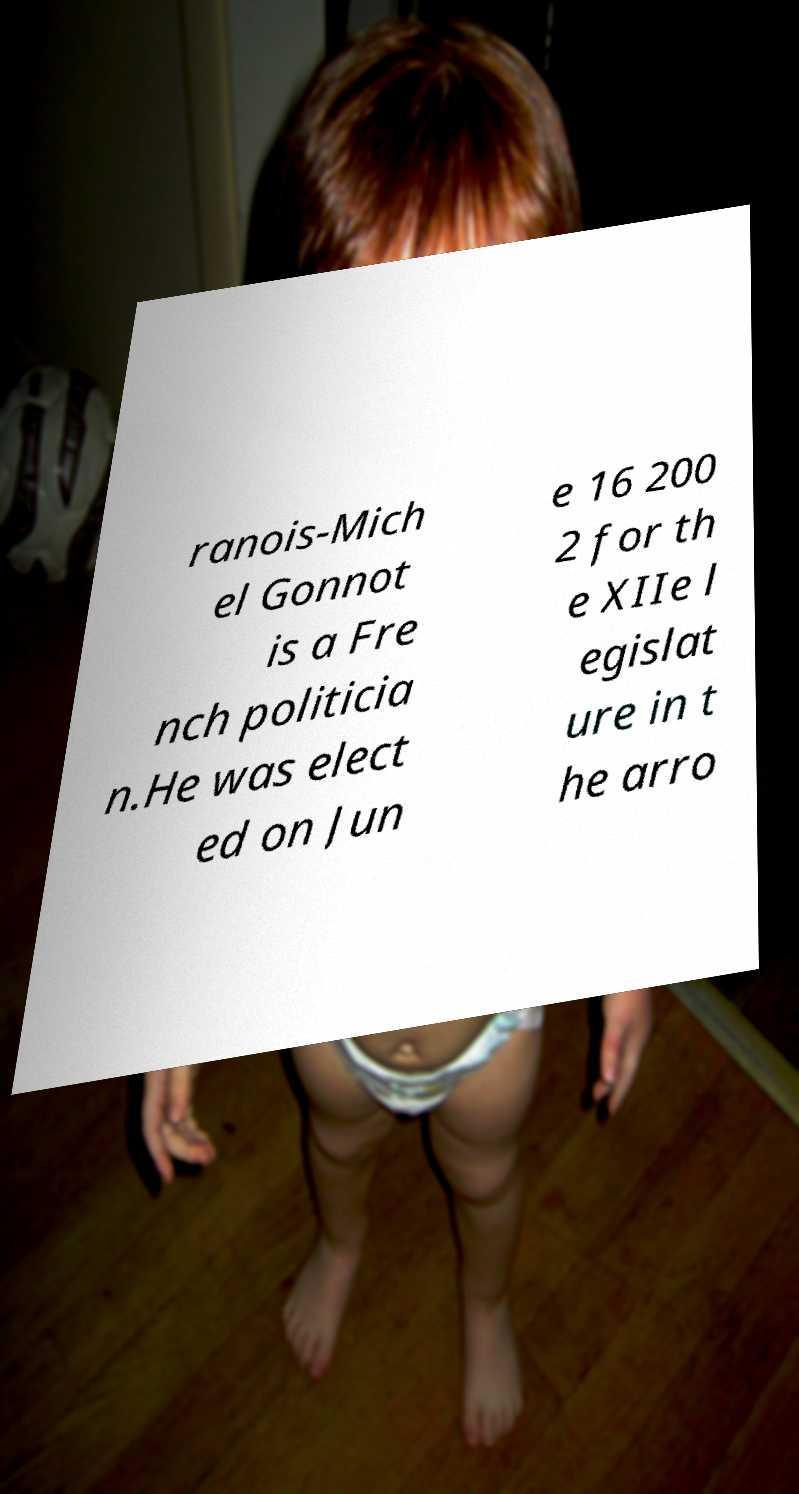Could you assist in decoding the text presented in this image and type it out clearly? ranois-Mich el Gonnot is a Fre nch politicia n.He was elect ed on Jun e 16 200 2 for th e XIIe l egislat ure in t he arro 